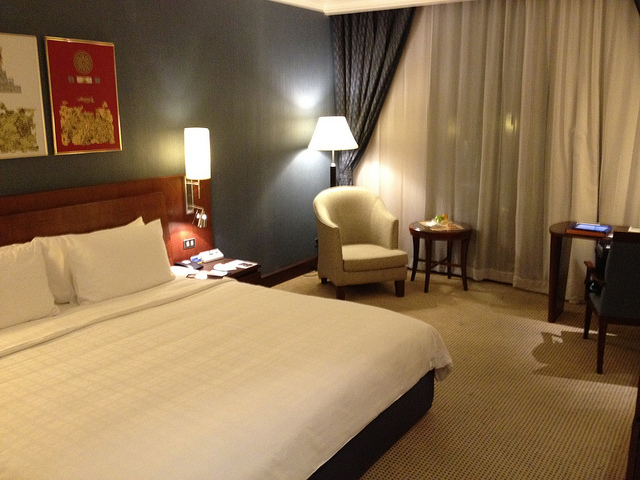How many beds are in this room? 1 